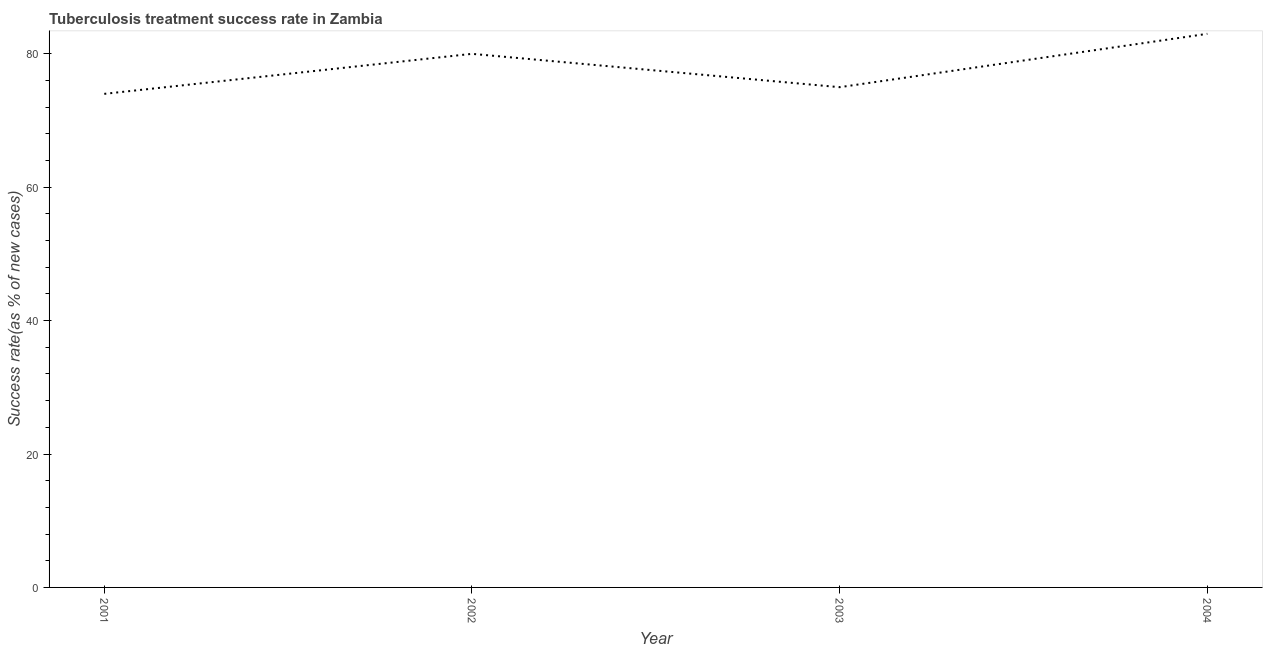What is the tuberculosis treatment success rate in 2004?
Your answer should be compact. 83. Across all years, what is the maximum tuberculosis treatment success rate?
Ensure brevity in your answer.  83. Across all years, what is the minimum tuberculosis treatment success rate?
Offer a terse response. 74. What is the sum of the tuberculosis treatment success rate?
Keep it short and to the point. 312. What is the difference between the tuberculosis treatment success rate in 2001 and 2003?
Offer a very short reply. -1. What is the average tuberculosis treatment success rate per year?
Provide a succinct answer. 78. What is the median tuberculosis treatment success rate?
Your answer should be compact. 77.5. In how many years, is the tuberculosis treatment success rate greater than 36 %?
Offer a very short reply. 4. Do a majority of the years between 2001 and 2004 (inclusive) have tuberculosis treatment success rate greater than 12 %?
Offer a terse response. Yes. What is the ratio of the tuberculosis treatment success rate in 2003 to that in 2004?
Your answer should be very brief. 0.9. Is the tuberculosis treatment success rate in 2002 less than that in 2003?
Ensure brevity in your answer.  No. Is the sum of the tuberculosis treatment success rate in 2002 and 2003 greater than the maximum tuberculosis treatment success rate across all years?
Provide a short and direct response. Yes. What is the difference between the highest and the lowest tuberculosis treatment success rate?
Provide a succinct answer. 9. How many years are there in the graph?
Ensure brevity in your answer.  4. Are the values on the major ticks of Y-axis written in scientific E-notation?
Give a very brief answer. No. Does the graph contain any zero values?
Ensure brevity in your answer.  No. What is the title of the graph?
Keep it short and to the point. Tuberculosis treatment success rate in Zambia. What is the label or title of the Y-axis?
Ensure brevity in your answer.  Success rate(as % of new cases). What is the Success rate(as % of new cases) of 2001?
Your answer should be compact. 74. What is the Success rate(as % of new cases) of 2003?
Provide a succinct answer. 75. What is the Success rate(as % of new cases) in 2004?
Offer a very short reply. 83. What is the difference between the Success rate(as % of new cases) in 2001 and 2003?
Provide a short and direct response. -1. What is the difference between the Success rate(as % of new cases) in 2002 and 2003?
Your response must be concise. 5. What is the difference between the Success rate(as % of new cases) in 2003 and 2004?
Provide a succinct answer. -8. What is the ratio of the Success rate(as % of new cases) in 2001 to that in 2002?
Offer a very short reply. 0.93. What is the ratio of the Success rate(as % of new cases) in 2001 to that in 2003?
Your response must be concise. 0.99. What is the ratio of the Success rate(as % of new cases) in 2001 to that in 2004?
Your response must be concise. 0.89. What is the ratio of the Success rate(as % of new cases) in 2002 to that in 2003?
Make the answer very short. 1.07. What is the ratio of the Success rate(as % of new cases) in 2002 to that in 2004?
Your response must be concise. 0.96. What is the ratio of the Success rate(as % of new cases) in 2003 to that in 2004?
Your response must be concise. 0.9. 